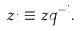Convert formula to latex. <formula><loc_0><loc_0><loc_500><loc_500>z _ { i } \equiv z q ^ { - i } .</formula> 